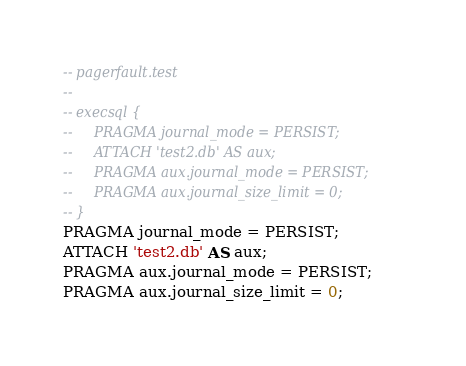Convert code to text. <code><loc_0><loc_0><loc_500><loc_500><_SQL_>-- pagerfault.test
-- 
-- execsql { 
--     PRAGMA journal_mode = PERSIST;
--     ATTACH 'test2.db' AS aux;
--     PRAGMA aux.journal_mode = PERSIST;
--     PRAGMA aux.journal_size_limit = 0;
-- }
PRAGMA journal_mode = PERSIST;
ATTACH 'test2.db' AS aux;
PRAGMA aux.journal_mode = PERSIST;
PRAGMA aux.journal_size_limit = 0;</code> 